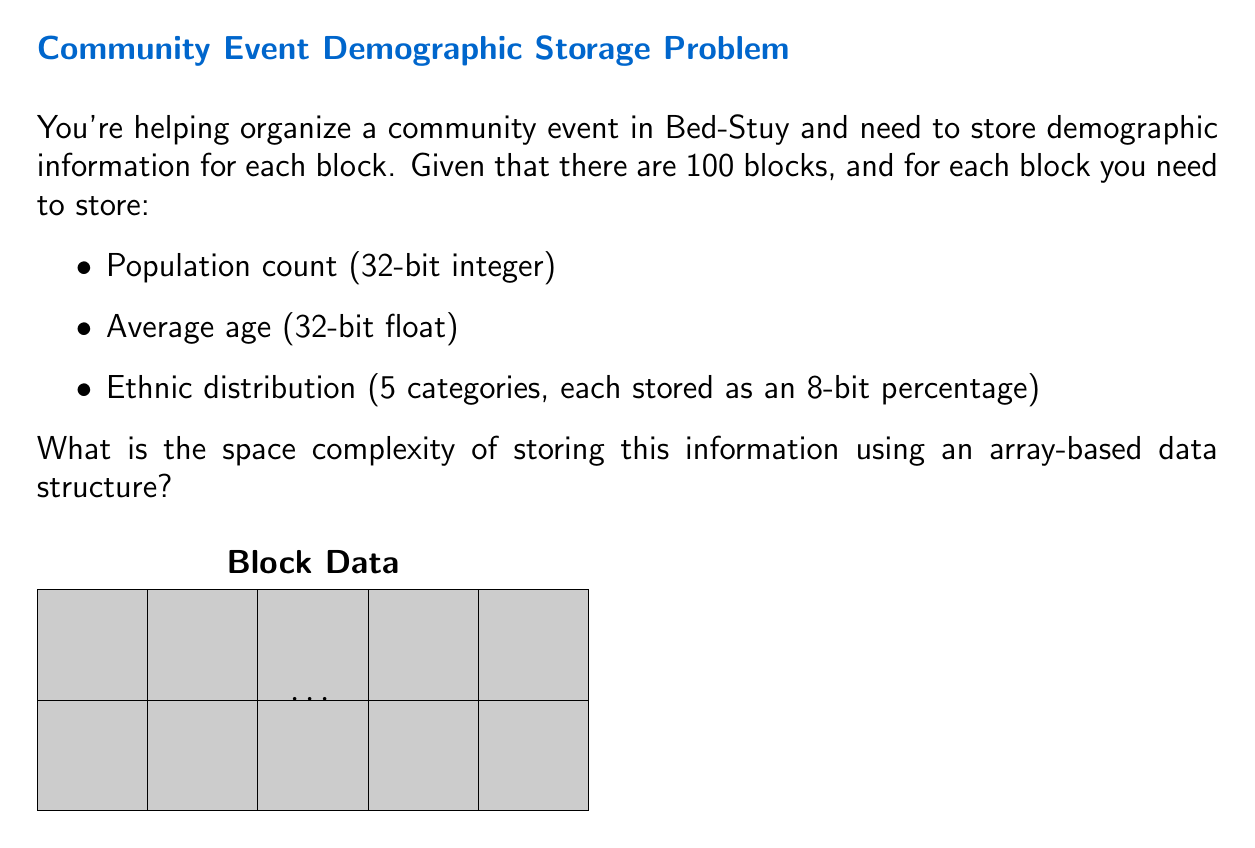Provide a solution to this math problem. Let's break this down step-by-step:

1) For each block, we need to store:
   - Population count: 32 bits = 4 bytes
   - Average age: 32 bits = 4 bytes
   - Ethnic distribution: 5 * 8 bits = 40 bits = 5 bytes

2) Total storage per block:
   $4 + 4 + 5 = 13$ bytes

3) We have 100 blocks in total, so the total storage needed is:
   $100 * 13 = 1300$ bytes

4) In big O notation, we express this as $O(n)$, where $n$ is the number of blocks. This is because the space required grows linearly with the number of blocks.

5) The constant factors (like the 13 bytes per block) are dropped in big O notation, as we're concerned with the growth rate, not the exact size.

Therefore, the space complexity is $O(n)$, where $n$ is the number of blocks.
Answer: $O(n)$ 